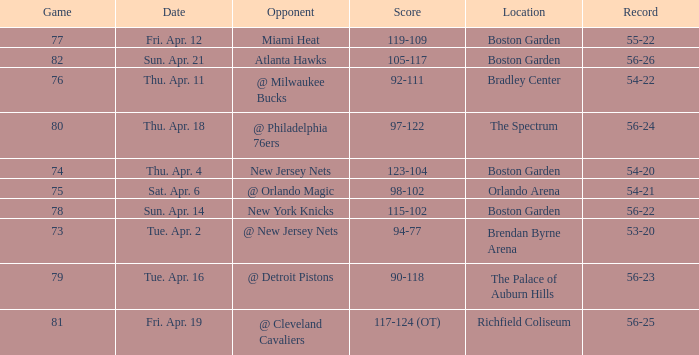Which Score has a Location of richfield coliseum? 117-124 (OT). 